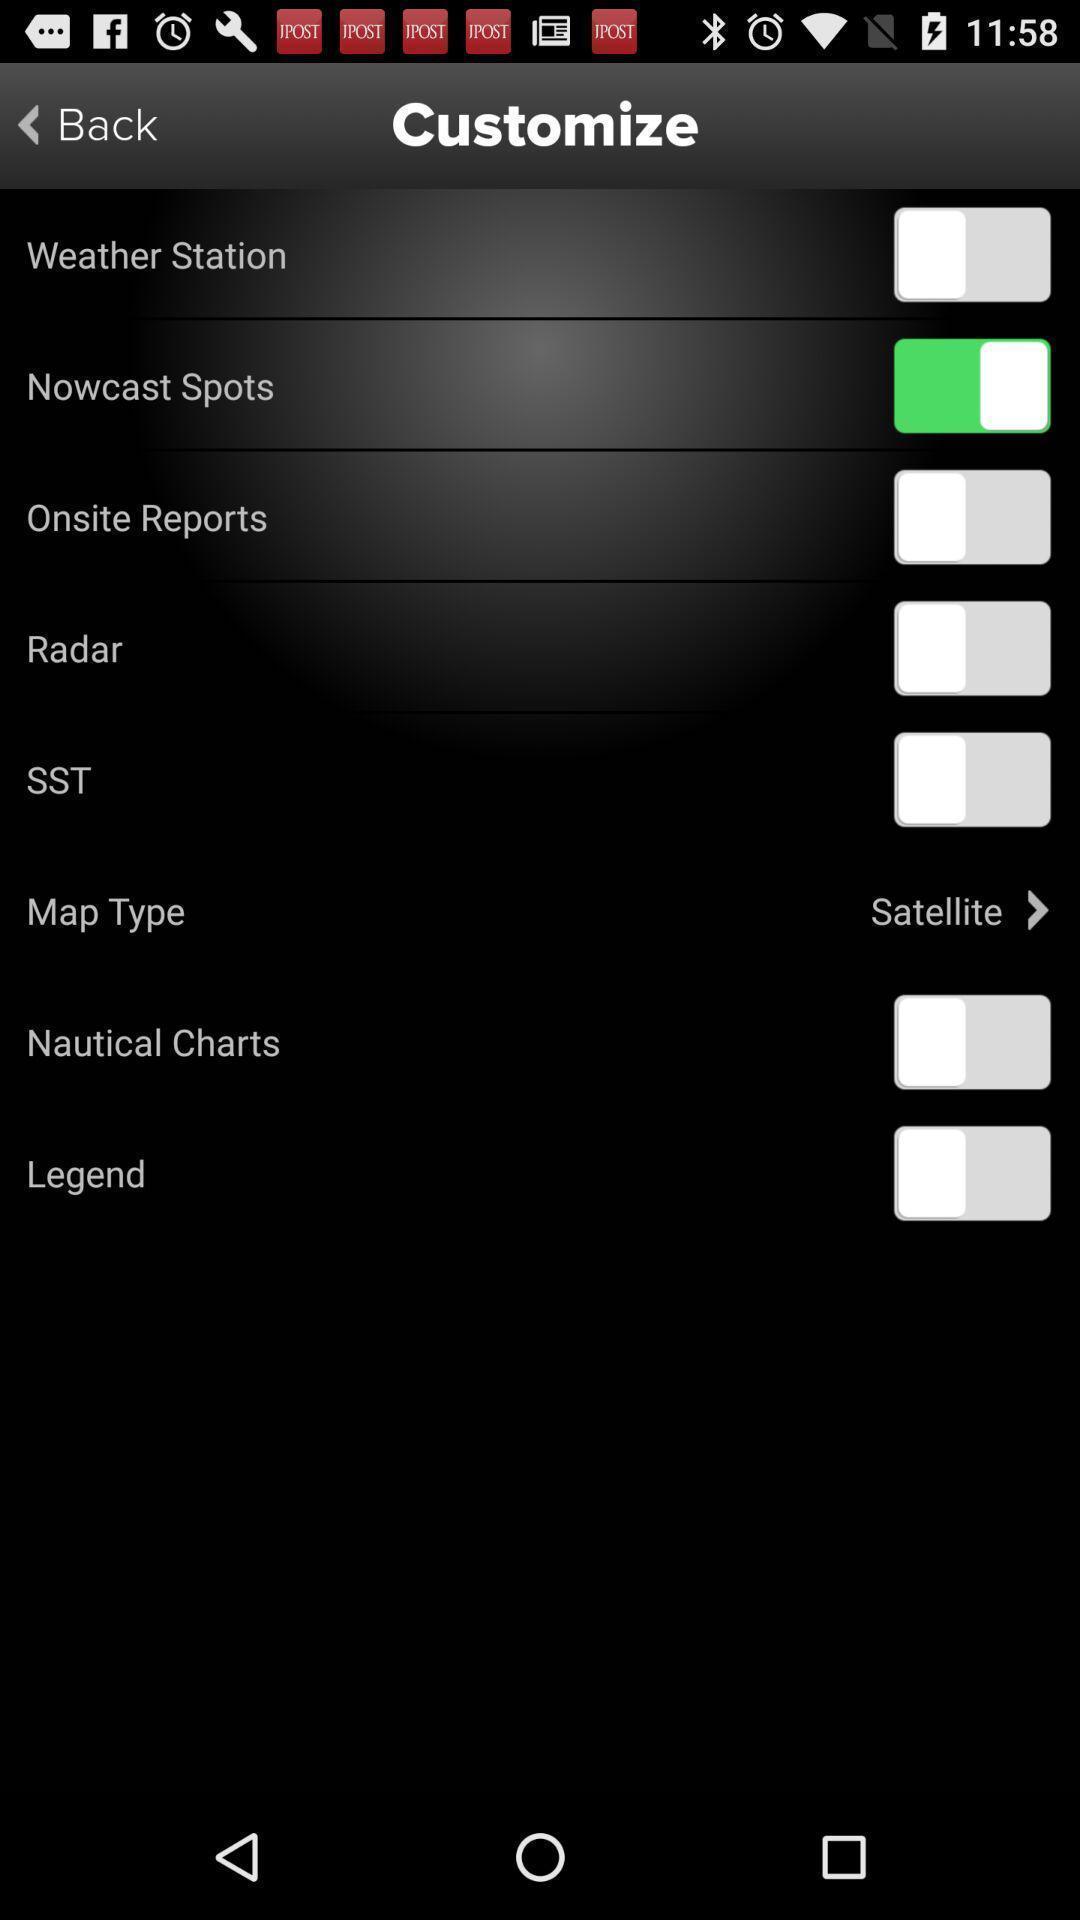What details can you identify in this image? Screen shows weather details in an weather app. 